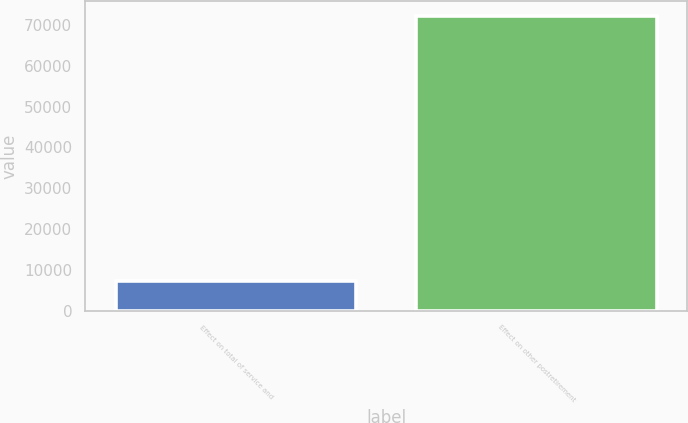Convert chart to OTSL. <chart><loc_0><loc_0><loc_500><loc_500><bar_chart><fcel>Effect on total of service and<fcel>Effect on other postretirement<nl><fcel>7367<fcel>72238<nl></chart> 